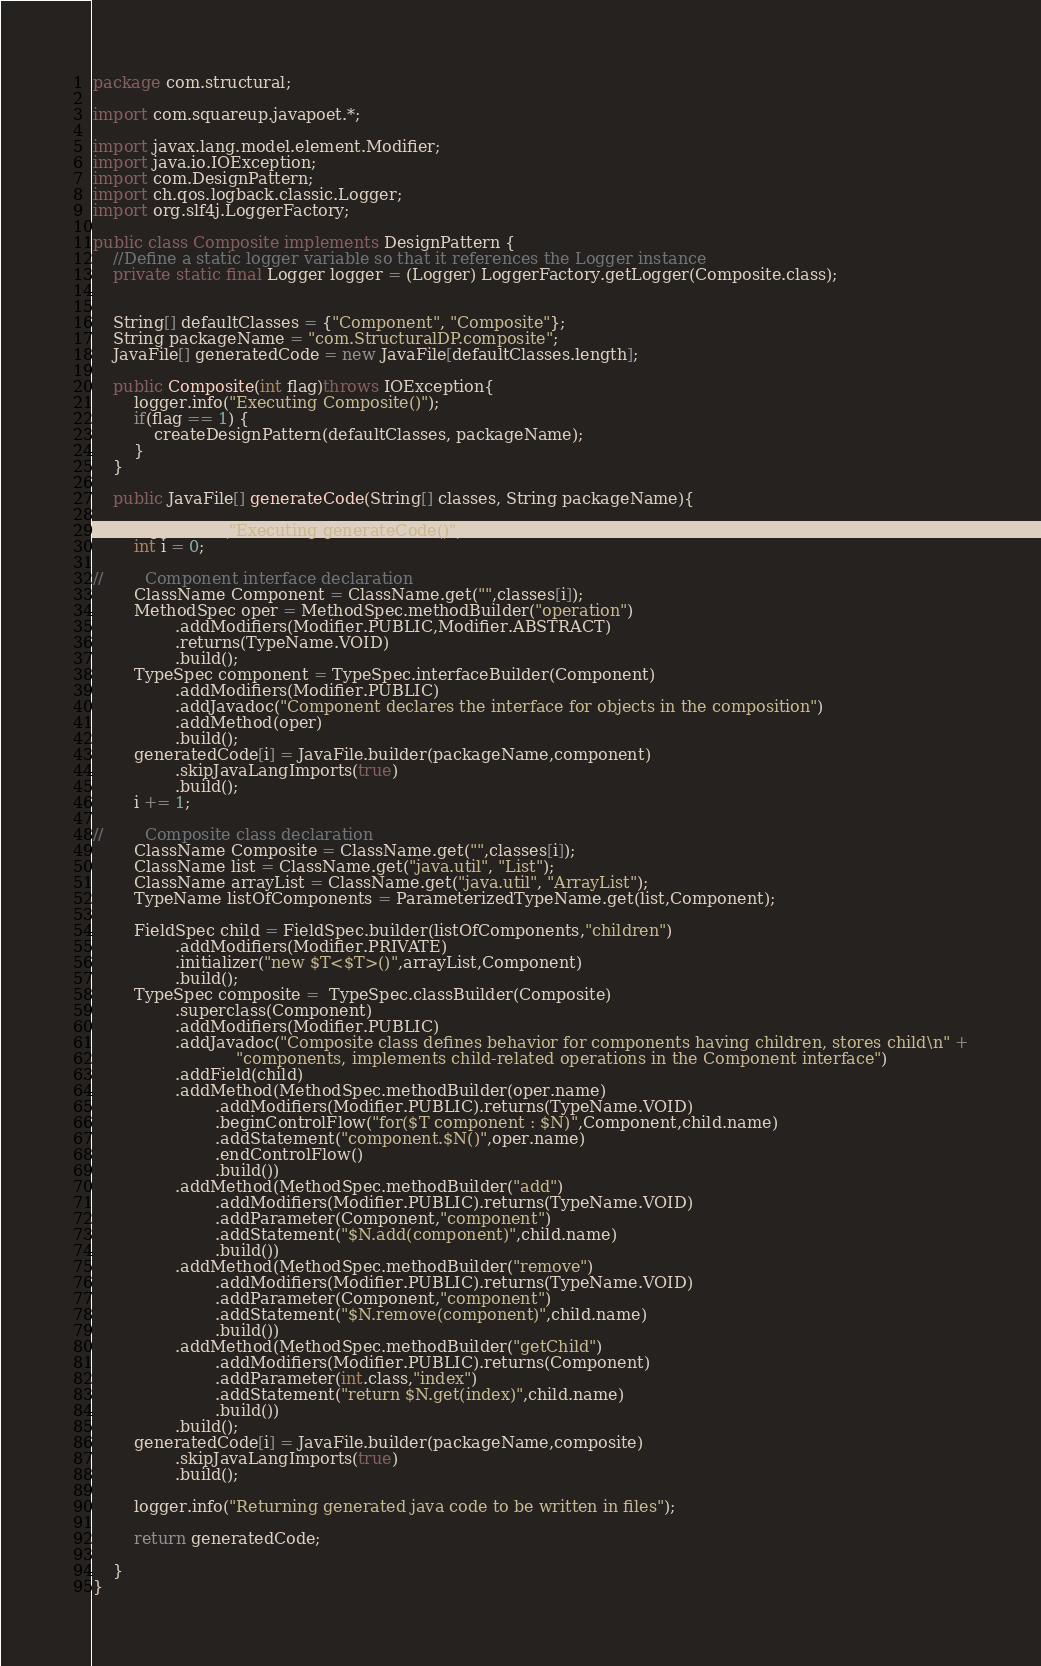<code> <loc_0><loc_0><loc_500><loc_500><_Java_>package com.structural;

import com.squareup.javapoet.*;

import javax.lang.model.element.Modifier;
import java.io.IOException;
import com.DesignPattern;
import ch.qos.logback.classic.Logger;
import org.slf4j.LoggerFactory;

public class Composite implements DesignPattern {
    //Define a static logger variable so that it references the Logger instance
    private static final Logger logger = (Logger) LoggerFactory.getLogger(Composite.class);


    String[] defaultClasses = {"Component", "Composite"};
    String packageName = "com.StructuralDP.composite";
    JavaFile[] generatedCode = new JavaFile[defaultClasses.length];

    public Composite(int flag)throws IOException{
        logger.info("Executing Composite()");
        if(flag == 1) {
            createDesignPattern(defaultClasses, packageName);
        }
    }

    public JavaFile[] generateCode(String[] classes, String packageName){

        logger.info("Executing generateCode()");
        int i = 0;

//        Component interface declaration
        ClassName Component = ClassName.get("",classes[i]);
        MethodSpec oper = MethodSpec.methodBuilder("operation")
                .addModifiers(Modifier.PUBLIC,Modifier.ABSTRACT)
                .returns(TypeName.VOID)
                .build();
        TypeSpec component = TypeSpec.interfaceBuilder(Component)
                .addModifiers(Modifier.PUBLIC)
                .addJavadoc("Component declares the interface for objects in the composition")
                .addMethod(oper)
                .build();
        generatedCode[i] = JavaFile.builder(packageName,component)
                .skipJavaLangImports(true)
                .build();
        i += 1;

//        Composite class declaration
        ClassName Composite = ClassName.get("",classes[i]);
        ClassName list = ClassName.get("java.util", "List");
        ClassName arrayList = ClassName.get("java.util", "ArrayList");
        TypeName listOfComponents = ParameterizedTypeName.get(list,Component);

        FieldSpec child = FieldSpec.builder(listOfComponents,"children")
                .addModifiers(Modifier.PRIVATE)
                .initializer("new $T<$T>()",arrayList,Component)
                .build();
        TypeSpec composite =  TypeSpec.classBuilder(Composite)
                .superclass(Component)
                .addModifiers(Modifier.PUBLIC)
                .addJavadoc("Composite class defines behavior for components having children, stores child\n" +
                            "components, implements child-related operations in the Component interface")
                .addField(child)
                .addMethod(MethodSpec.methodBuilder(oper.name)
                        .addModifiers(Modifier.PUBLIC).returns(TypeName.VOID)
                        .beginControlFlow("for($T component : $N)",Component,child.name)
                        .addStatement("component.$N()",oper.name)
                        .endControlFlow()
                        .build())
                .addMethod(MethodSpec.methodBuilder("add")
                        .addModifiers(Modifier.PUBLIC).returns(TypeName.VOID)
                        .addParameter(Component,"component")
                        .addStatement("$N.add(component)",child.name)
                        .build())
                .addMethod(MethodSpec.methodBuilder("remove")
                        .addModifiers(Modifier.PUBLIC).returns(TypeName.VOID)
                        .addParameter(Component,"component")
                        .addStatement("$N.remove(component)",child.name)
                        .build())
                .addMethod(MethodSpec.methodBuilder("getChild")
                        .addModifiers(Modifier.PUBLIC).returns(Component)
                        .addParameter(int.class,"index")
                        .addStatement("return $N.get(index)",child.name)
                        .build())
                .build();
        generatedCode[i] = JavaFile.builder(packageName,composite)
                .skipJavaLangImports(true)
                .build();

        logger.info("Returning generated java code to be written in files");

        return generatedCode;

    }
}
</code> 